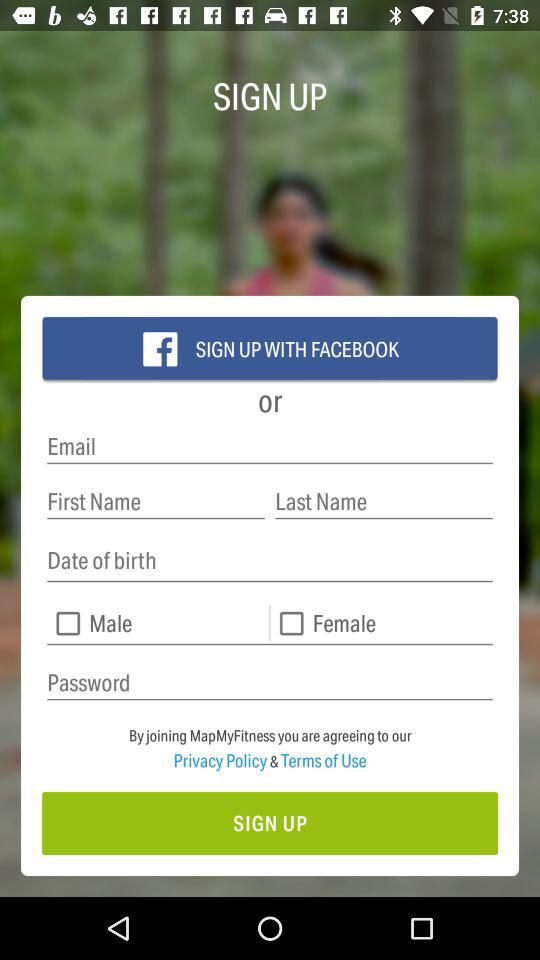How many characters are required to create a password?
When the provided information is insufficient, respond with <no answer>. <no answer> 